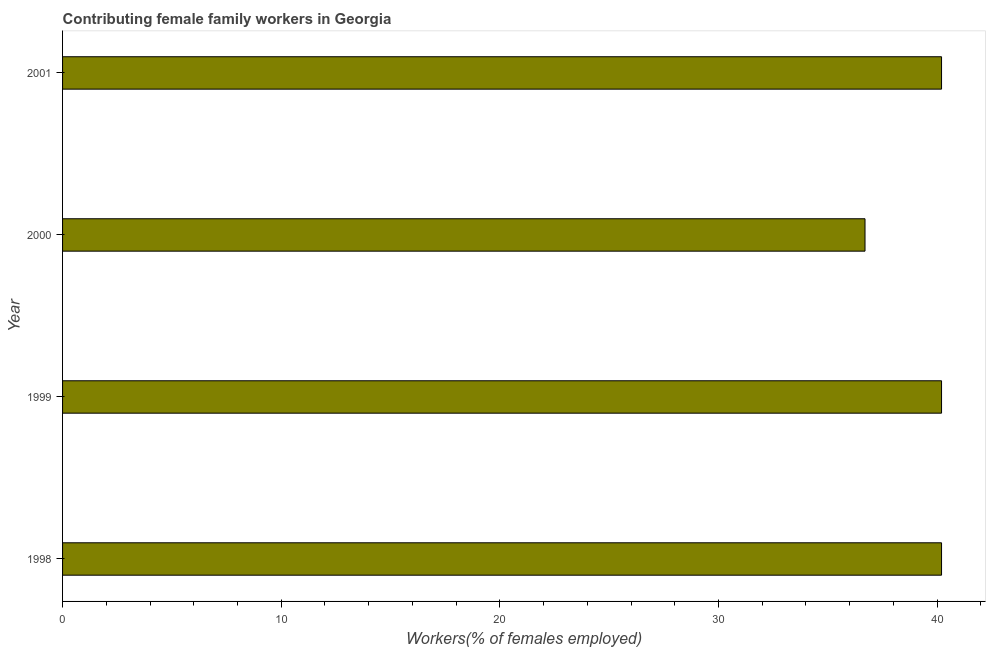What is the title of the graph?
Your response must be concise. Contributing female family workers in Georgia. What is the label or title of the X-axis?
Offer a very short reply. Workers(% of females employed). What is the label or title of the Y-axis?
Offer a very short reply. Year. What is the contributing female family workers in 1998?
Your response must be concise. 40.2. Across all years, what is the maximum contributing female family workers?
Keep it short and to the point. 40.2. Across all years, what is the minimum contributing female family workers?
Keep it short and to the point. 36.7. In which year was the contributing female family workers minimum?
Ensure brevity in your answer.  2000. What is the sum of the contributing female family workers?
Make the answer very short. 157.3. What is the average contributing female family workers per year?
Make the answer very short. 39.33. What is the median contributing female family workers?
Your answer should be very brief. 40.2. What is the ratio of the contributing female family workers in 1998 to that in 2001?
Give a very brief answer. 1. Is the difference between the contributing female family workers in 1998 and 2001 greater than the difference between any two years?
Your answer should be very brief. No. Is the sum of the contributing female family workers in 1999 and 2000 greater than the maximum contributing female family workers across all years?
Offer a terse response. Yes. What is the difference between the highest and the lowest contributing female family workers?
Offer a terse response. 3.5. How many bars are there?
Your answer should be very brief. 4. What is the difference between two consecutive major ticks on the X-axis?
Provide a short and direct response. 10. Are the values on the major ticks of X-axis written in scientific E-notation?
Provide a short and direct response. No. What is the Workers(% of females employed) of 1998?
Your response must be concise. 40.2. What is the Workers(% of females employed) in 1999?
Offer a very short reply. 40.2. What is the Workers(% of females employed) of 2000?
Provide a short and direct response. 36.7. What is the Workers(% of females employed) of 2001?
Your response must be concise. 40.2. What is the difference between the Workers(% of females employed) in 1998 and 2001?
Your response must be concise. 0. What is the difference between the Workers(% of females employed) in 1999 and 2001?
Your answer should be compact. 0. What is the difference between the Workers(% of females employed) in 2000 and 2001?
Your answer should be compact. -3.5. What is the ratio of the Workers(% of females employed) in 1998 to that in 1999?
Ensure brevity in your answer.  1. What is the ratio of the Workers(% of females employed) in 1998 to that in 2000?
Ensure brevity in your answer.  1.09. What is the ratio of the Workers(% of females employed) in 1999 to that in 2000?
Your response must be concise. 1.09. What is the ratio of the Workers(% of females employed) in 2000 to that in 2001?
Keep it short and to the point. 0.91. 